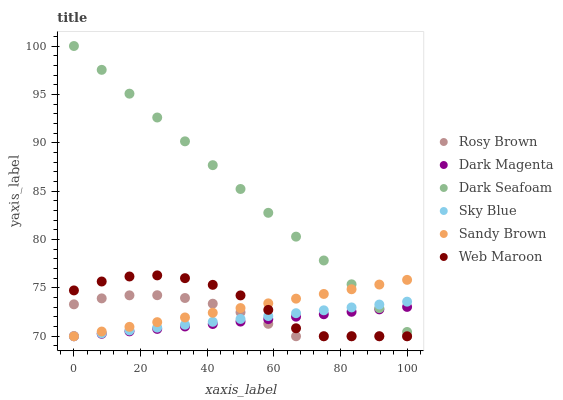Does Dark Magenta have the minimum area under the curve?
Answer yes or no. Yes. Does Dark Seafoam have the maximum area under the curve?
Answer yes or no. Yes. Does Rosy Brown have the minimum area under the curve?
Answer yes or no. No. Does Rosy Brown have the maximum area under the curve?
Answer yes or no. No. Is Sandy Brown the smoothest?
Answer yes or no. Yes. Is Web Maroon the roughest?
Answer yes or no. Yes. Is Rosy Brown the smoothest?
Answer yes or no. No. Is Rosy Brown the roughest?
Answer yes or no. No. Does Dark Magenta have the lowest value?
Answer yes or no. Yes. Does Dark Seafoam have the lowest value?
Answer yes or no. No. Does Dark Seafoam have the highest value?
Answer yes or no. Yes. Does Rosy Brown have the highest value?
Answer yes or no. No. Is Web Maroon less than Dark Seafoam?
Answer yes or no. Yes. Is Dark Seafoam greater than Web Maroon?
Answer yes or no. Yes. Does Sandy Brown intersect Sky Blue?
Answer yes or no. Yes. Is Sandy Brown less than Sky Blue?
Answer yes or no. No. Is Sandy Brown greater than Sky Blue?
Answer yes or no. No. Does Web Maroon intersect Dark Seafoam?
Answer yes or no. No. 